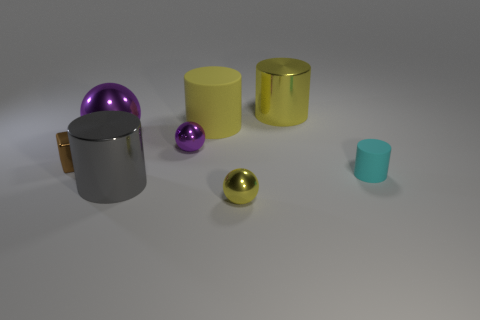Add 2 large purple objects. How many objects exist? 10 Subtract all spheres. How many objects are left? 5 Add 6 rubber cylinders. How many rubber cylinders are left? 8 Add 7 small purple metallic objects. How many small purple metallic objects exist? 8 Subtract 0 brown spheres. How many objects are left? 8 Subtract all big yellow things. Subtract all brown blocks. How many objects are left? 5 